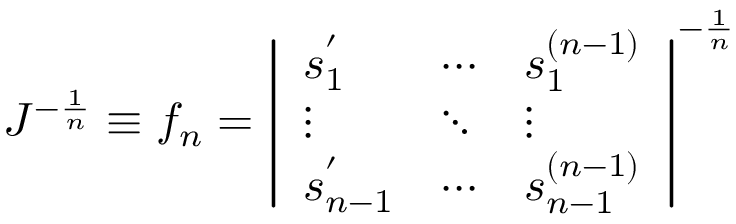<formula> <loc_0><loc_0><loc_500><loc_500>J ^ { - { \frac { 1 } { n } } } \equiv f _ { n } = \left | \begin{array} { l l l } { { s _ { 1 } ^ { ^ { \prime } } } } & { \cdots } & { { s _ { 1 } ^ { ( n - 1 ) } } } \\ { \vdots } & { \ddots } & { \vdots } \\ { { s _ { n - 1 } ^ { ^ { \prime } } } } & { \cdots } & { { s _ { n - 1 } ^ { ( n - 1 ) } } } \end{array} \right | ^ { - { \frac { 1 } { n } } }</formula> 